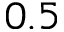<formula> <loc_0><loc_0><loc_500><loc_500>0 . 5</formula> 